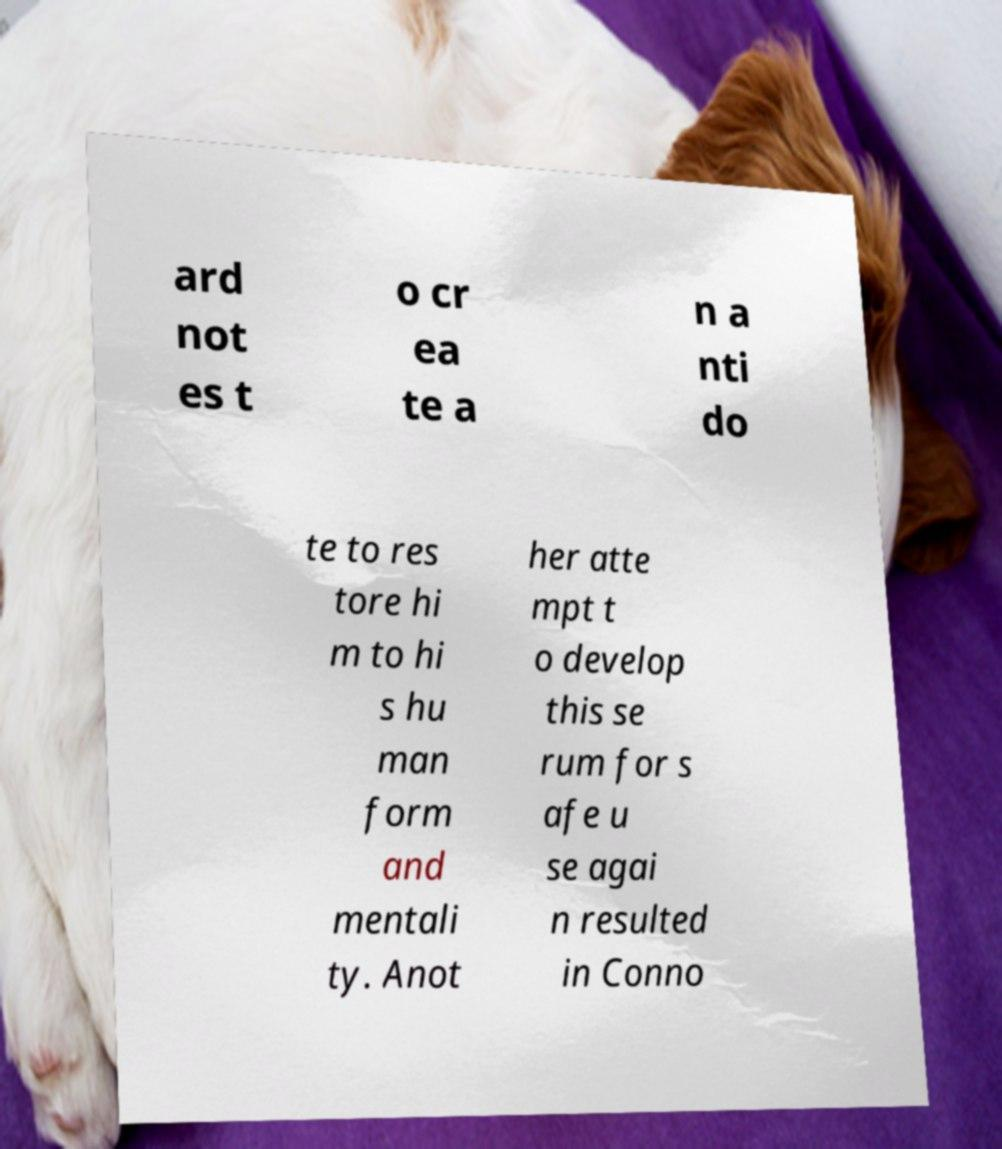Please identify and transcribe the text found in this image. ard not es t o cr ea te a n a nti do te to res tore hi m to hi s hu man form and mentali ty. Anot her atte mpt t o develop this se rum for s afe u se agai n resulted in Conno 